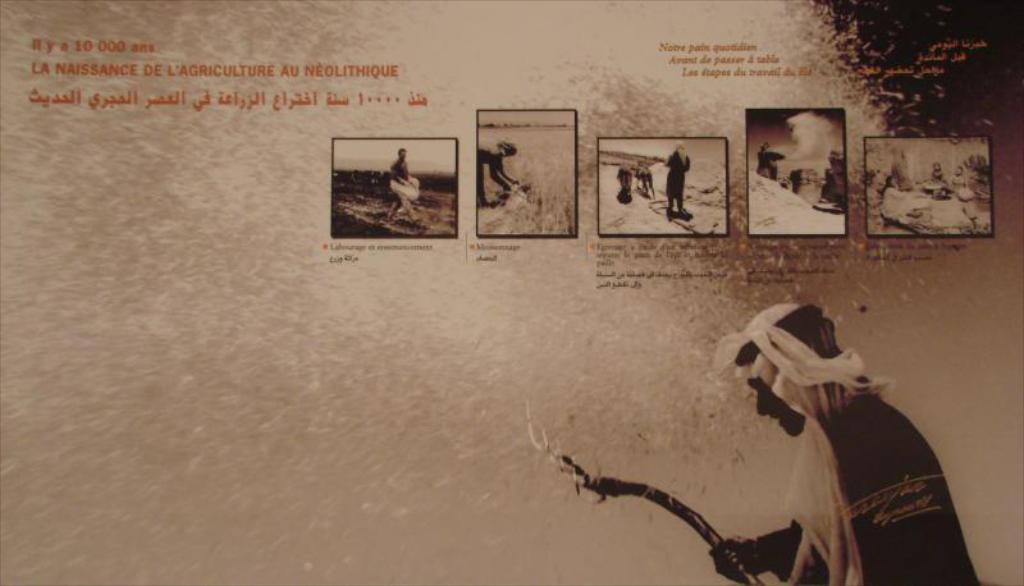Could you give a brief overview of what you see in this image? This is a picture of a poster , where there is a person standing and holding a stick , and there are images, words and numbers on the poster. 